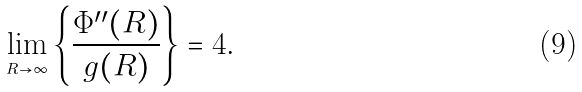<formula> <loc_0><loc_0><loc_500><loc_500>\lim _ { _ { R \rightarrow \infty } } \left \{ \frac { \Phi ^ { \prime \prime } ( R ) } { g ( R ) } \right \} = 4 .</formula> 